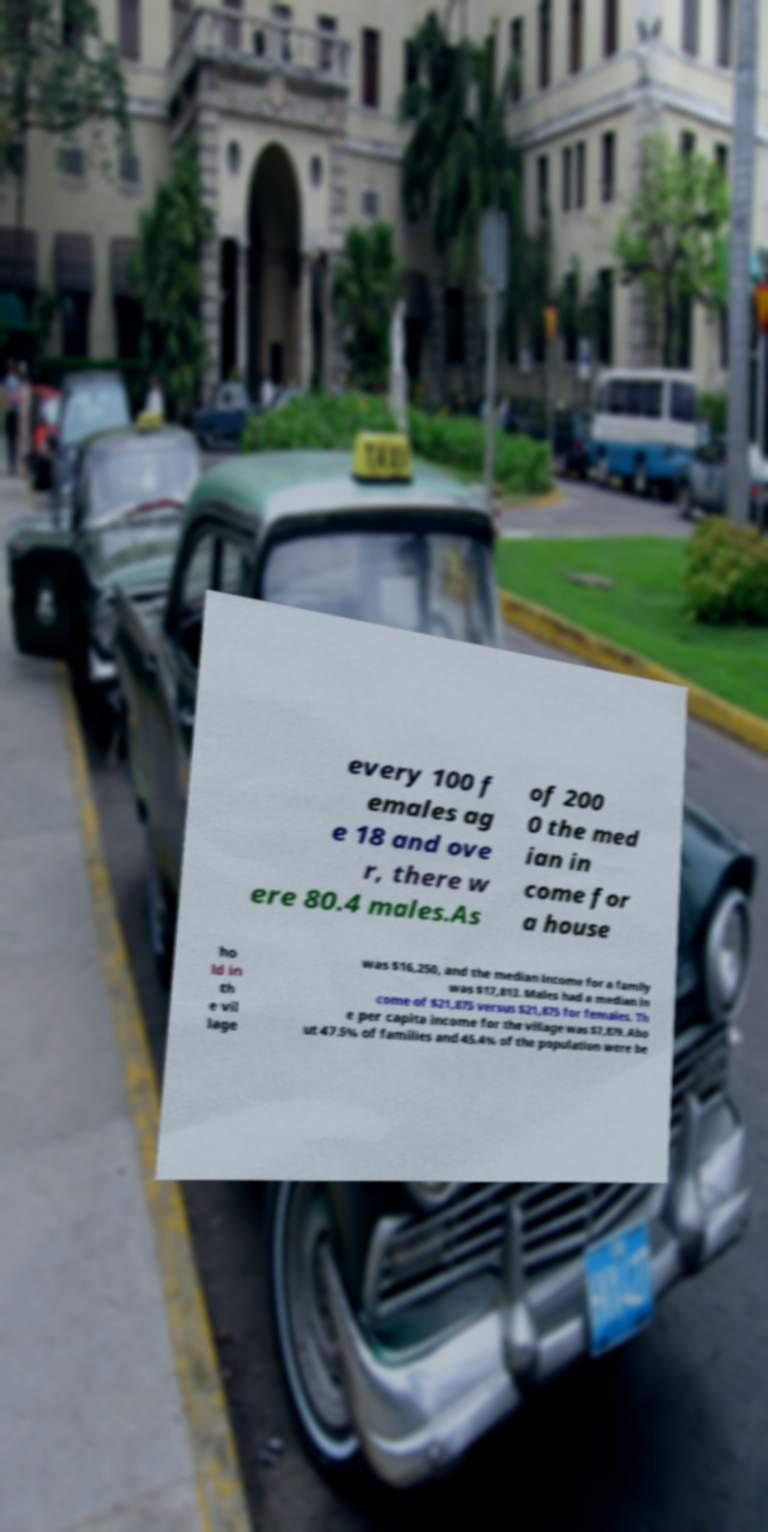Please read and relay the text visible in this image. What does it say? every 100 f emales ag e 18 and ove r, there w ere 80.4 males.As of 200 0 the med ian in come for a house ho ld in th e vil lage was $16,250, and the median income for a family was $17,813. Males had a median in come of $21,875 versus $21,875 for females. Th e per capita income for the village was $7,879. Abo ut 47.5% of families and 45.4% of the population were be 